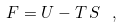<formula> <loc_0><loc_0><loc_500><loc_500>F = U - T \, S \ ,</formula> 